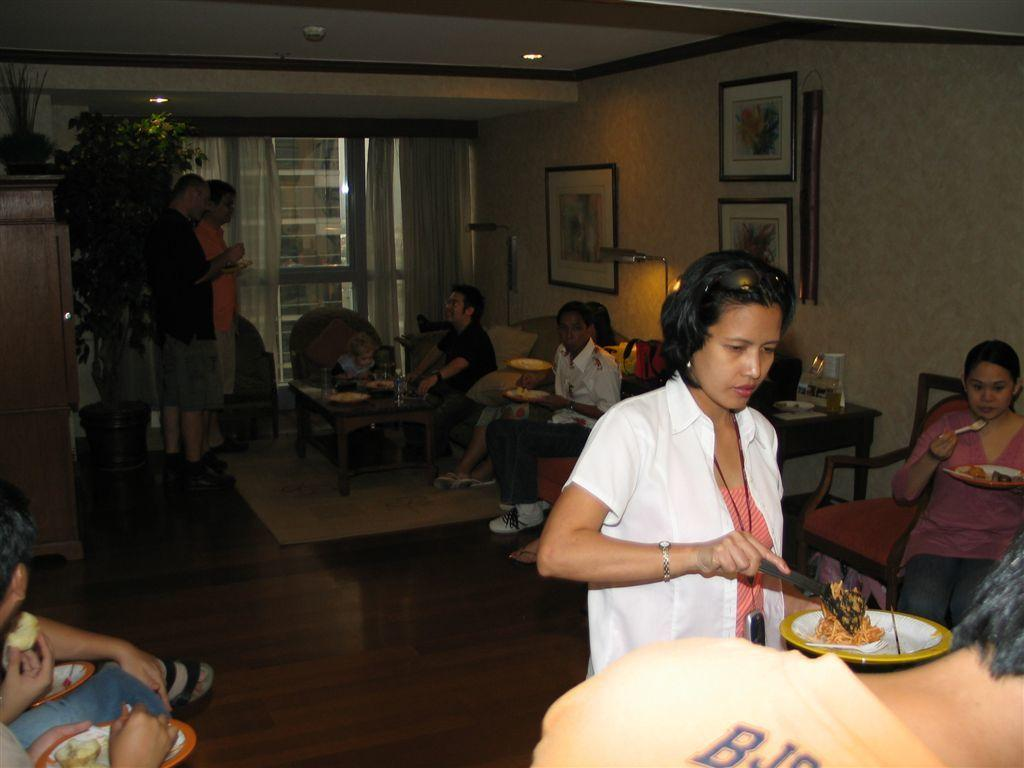Who is the main subject in the image? There is a woman in the image. What is the woman doing in the image? The woman is serving food. How is the food on the plate arranged? The plate has food divided into two halves. What can be seen in the background of the image? There are people sitting and standing in the background of the image. What type of apparatus is being used to cook the meat in the image? There is no apparatus or meat present in the image. Can you tell me what type of animals are in the zoo in the image? There is no zoo or animals present in the image. 